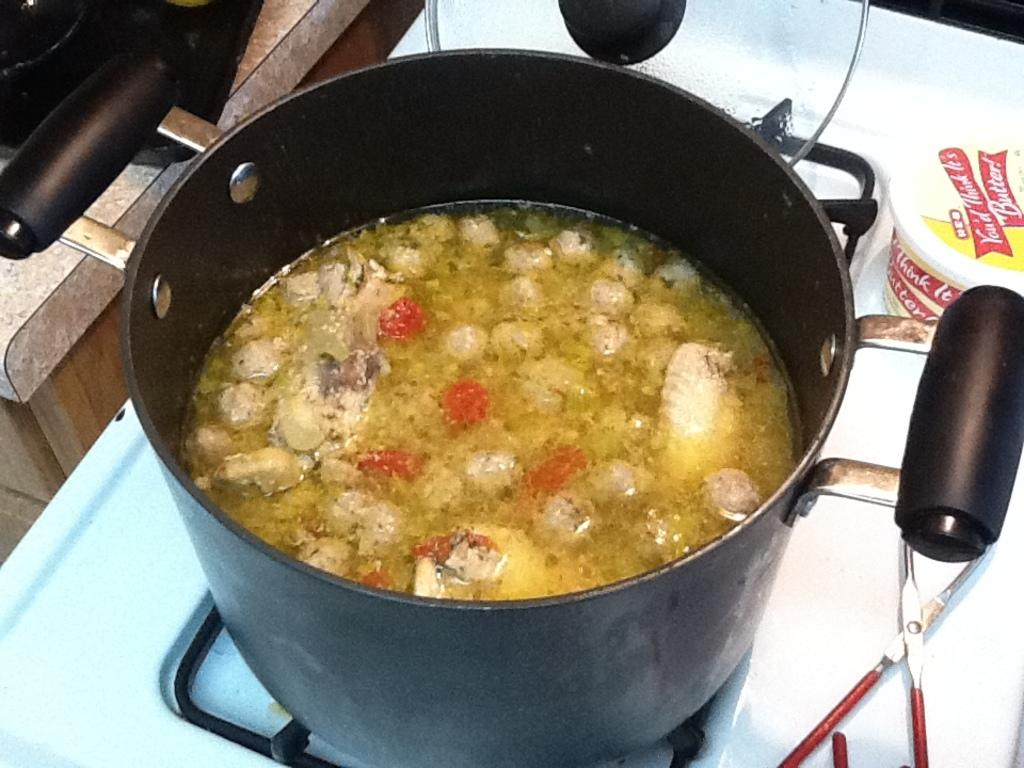What is the main object in the image? There is a vessel in the image. What is inside the vessel? There is a food item in the vessel. What appliance is present in the image? There is a stove in the image. What else can be seen near the stove? There are objects beside the stove. How many icicles are hanging from the vessel in the image? There are no icicles present in the image; it features a vessel with a food item inside. What type of beds can be seen in the image? There are no beds present in the image. 